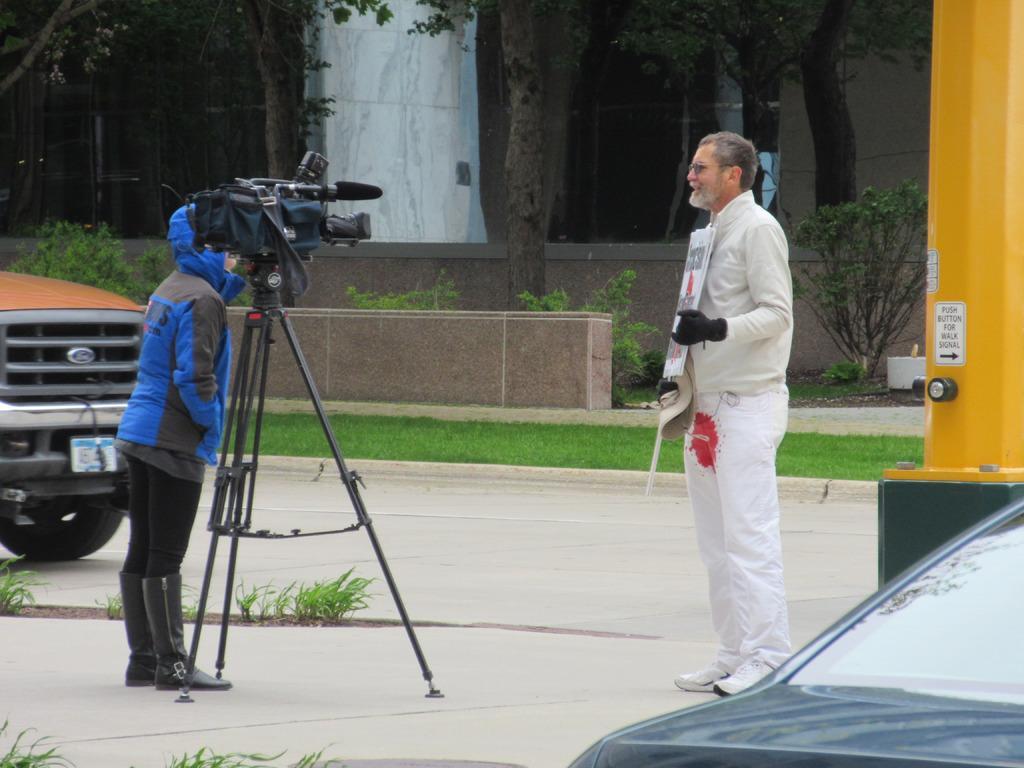Describe this image in one or two sentences. In this image, I can see two persons standing. There is a video recorder on a tripod stand. On the right side of the image, I can see a vehicle on the road. In the background, I can see trees, plants, grass and a building. On the right side of the image, there is a pillar. 